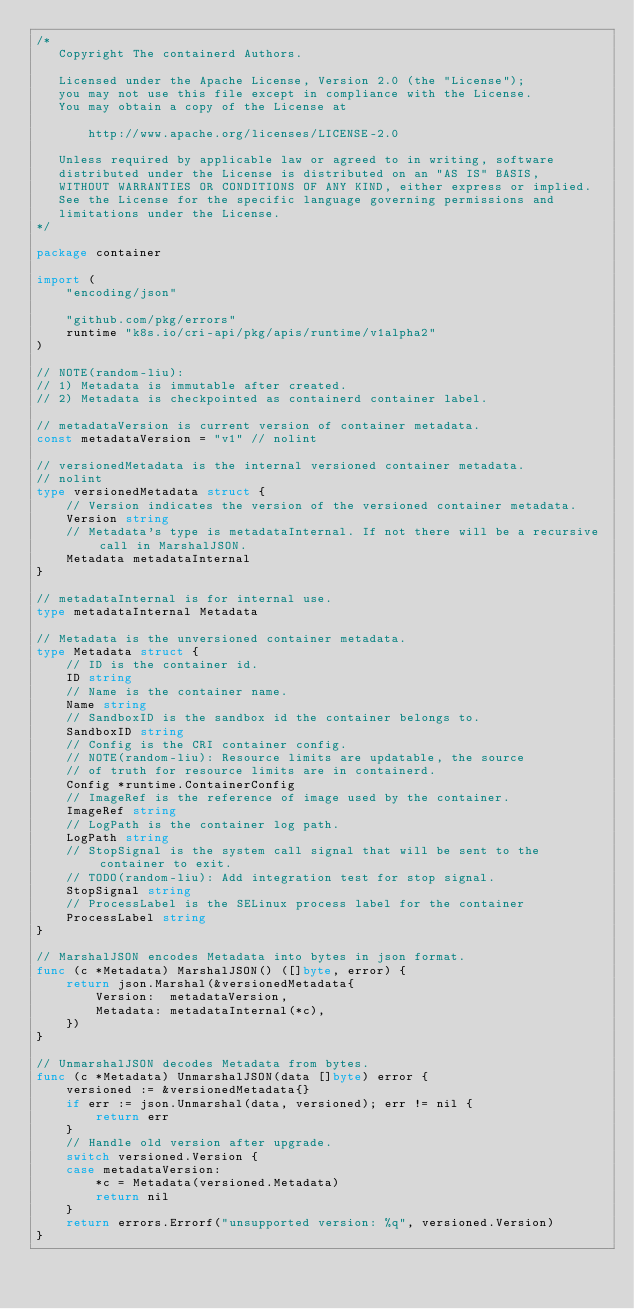<code> <loc_0><loc_0><loc_500><loc_500><_Go_>/*
   Copyright The containerd Authors.

   Licensed under the Apache License, Version 2.0 (the "License");
   you may not use this file except in compliance with the License.
   You may obtain a copy of the License at

       http://www.apache.org/licenses/LICENSE-2.0

   Unless required by applicable law or agreed to in writing, software
   distributed under the License is distributed on an "AS IS" BASIS,
   WITHOUT WARRANTIES OR CONDITIONS OF ANY KIND, either express or implied.
   See the License for the specific language governing permissions and
   limitations under the License.
*/

package container

import (
	"encoding/json"

	"github.com/pkg/errors"
	runtime "k8s.io/cri-api/pkg/apis/runtime/v1alpha2"
)

// NOTE(random-liu):
// 1) Metadata is immutable after created.
// 2) Metadata is checkpointed as containerd container label.

// metadataVersion is current version of container metadata.
const metadataVersion = "v1" // nolint

// versionedMetadata is the internal versioned container metadata.
// nolint
type versionedMetadata struct {
	// Version indicates the version of the versioned container metadata.
	Version string
	// Metadata's type is metadataInternal. If not there will be a recursive call in MarshalJSON.
	Metadata metadataInternal
}

// metadataInternal is for internal use.
type metadataInternal Metadata

// Metadata is the unversioned container metadata.
type Metadata struct {
	// ID is the container id.
	ID string
	// Name is the container name.
	Name string
	// SandboxID is the sandbox id the container belongs to.
	SandboxID string
	// Config is the CRI container config.
	// NOTE(random-liu): Resource limits are updatable, the source
	// of truth for resource limits are in containerd.
	Config *runtime.ContainerConfig
	// ImageRef is the reference of image used by the container.
	ImageRef string
	// LogPath is the container log path.
	LogPath string
	// StopSignal is the system call signal that will be sent to the container to exit.
	// TODO(random-liu): Add integration test for stop signal.
	StopSignal string
	// ProcessLabel is the SELinux process label for the container
	ProcessLabel string
}

// MarshalJSON encodes Metadata into bytes in json format.
func (c *Metadata) MarshalJSON() ([]byte, error) {
	return json.Marshal(&versionedMetadata{
		Version:  metadataVersion,
		Metadata: metadataInternal(*c),
	})
}

// UnmarshalJSON decodes Metadata from bytes.
func (c *Metadata) UnmarshalJSON(data []byte) error {
	versioned := &versionedMetadata{}
	if err := json.Unmarshal(data, versioned); err != nil {
		return err
	}
	// Handle old version after upgrade.
	switch versioned.Version {
	case metadataVersion:
		*c = Metadata(versioned.Metadata)
		return nil
	}
	return errors.Errorf("unsupported version: %q", versioned.Version)
}
</code> 